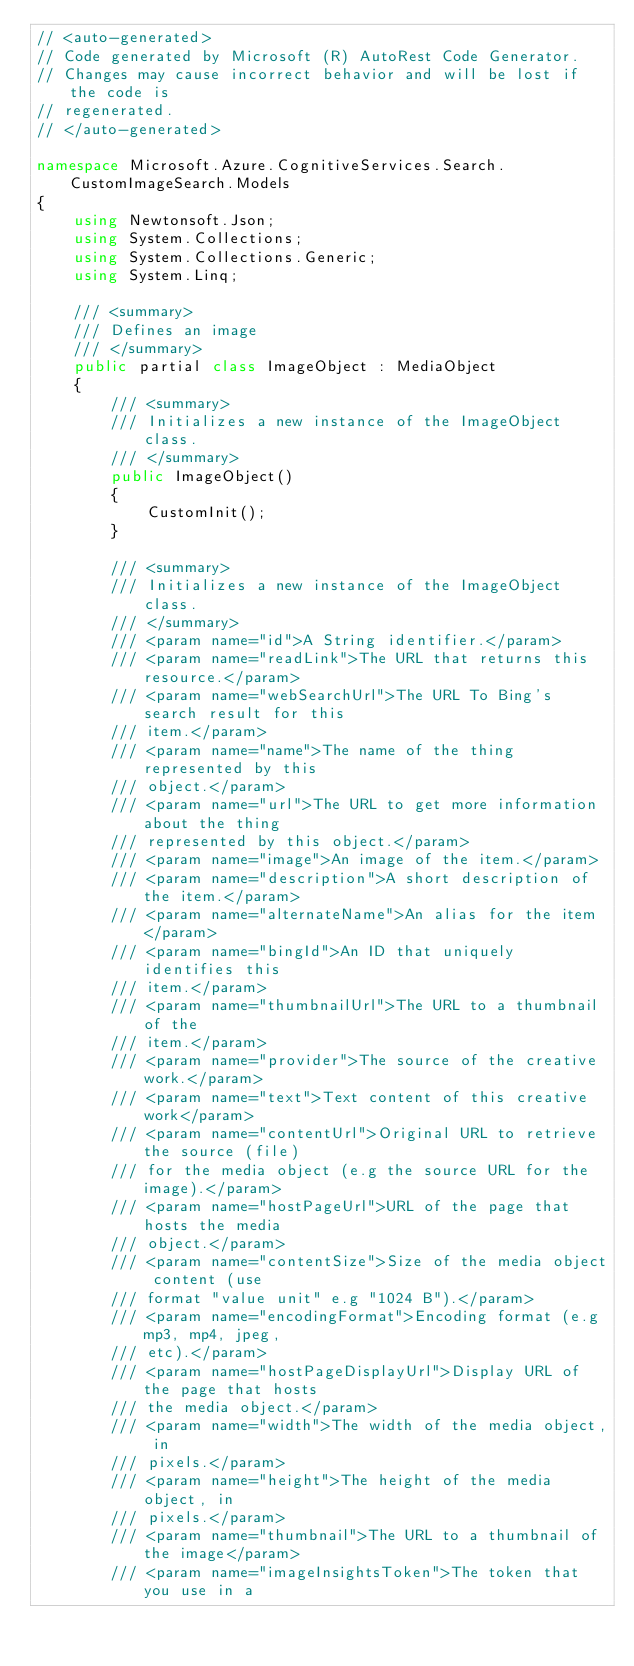Convert code to text. <code><loc_0><loc_0><loc_500><loc_500><_C#_>// <auto-generated>
// Code generated by Microsoft (R) AutoRest Code Generator.
// Changes may cause incorrect behavior and will be lost if the code is
// regenerated.
// </auto-generated>

namespace Microsoft.Azure.CognitiveServices.Search.CustomImageSearch.Models
{
    using Newtonsoft.Json;
    using System.Collections;
    using System.Collections.Generic;
    using System.Linq;

    /// <summary>
    /// Defines an image
    /// </summary>
    public partial class ImageObject : MediaObject
    {
        /// <summary>
        /// Initializes a new instance of the ImageObject class.
        /// </summary>
        public ImageObject()
        {
            CustomInit();
        }

        /// <summary>
        /// Initializes a new instance of the ImageObject class.
        /// </summary>
        /// <param name="id">A String identifier.</param>
        /// <param name="readLink">The URL that returns this resource.</param>
        /// <param name="webSearchUrl">The URL To Bing's search result for this
        /// item.</param>
        /// <param name="name">The name of the thing represented by this
        /// object.</param>
        /// <param name="url">The URL to get more information about the thing
        /// represented by this object.</param>
        /// <param name="image">An image of the item.</param>
        /// <param name="description">A short description of the item.</param>
        /// <param name="alternateName">An alias for the item</param>
        /// <param name="bingId">An ID that uniquely identifies this
        /// item.</param>
        /// <param name="thumbnailUrl">The URL to a thumbnail of the
        /// item.</param>
        /// <param name="provider">The source of the creative work.</param>
        /// <param name="text">Text content of this creative work</param>
        /// <param name="contentUrl">Original URL to retrieve the source (file)
        /// for the media object (e.g the source URL for the image).</param>
        /// <param name="hostPageUrl">URL of the page that hosts the media
        /// object.</param>
        /// <param name="contentSize">Size of the media object content (use
        /// format "value unit" e.g "1024 B").</param>
        /// <param name="encodingFormat">Encoding format (e.g mp3, mp4, jpeg,
        /// etc).</param>
        /// <param name="hostPageDisplayUrl">Display URL of the page that hosts
        /// the media object.</param>
        /// <param name="width">The width of the media object, in
        /// pixels.</param>
        /// <param name="height">The height of the media object, in
        /// pixels.</param>
        /// <param name="thumbnail">The URL to a thumbnail of the image</param>
        /// <param name="imageInsightsToken">The token that you use in a</code> 